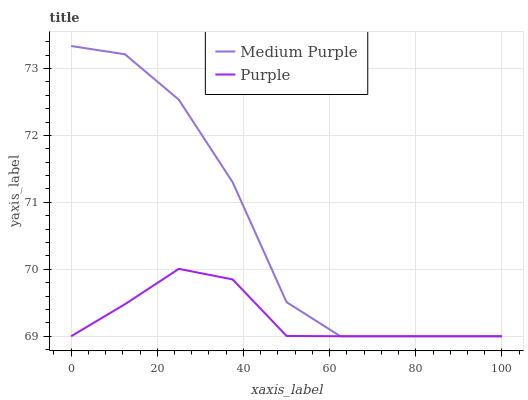Does Purple have the minimum area under the curve?
Answer yes or no. Yes. Does Medium Purple have the maximum area under the curve?
Answer yes or no. Yes. Does Purple have the maximum area under the curve?
Answer yes or no. No. Is Purple the smoothest?
Answer yes or no. Yes. Is Medium Purple the roughest?
Answer yes or no. Yes. Is Purple the roughest?
Answer yes or no. No. Does Medium Purple have the lowest value?
Answer yes or no. Yes. Does Medium Purple have the highest value?
Answer yes or no. Yes. Does Purple have the highest value?
Answer yes or no. No. Does Medium Purple intersect Purple?
Answer yes or no. Yes. Is Medium Purple less than Purple?
Answer yes or no. No. Is Medium Purple greater than Purple?
Answer yes or no. No. 